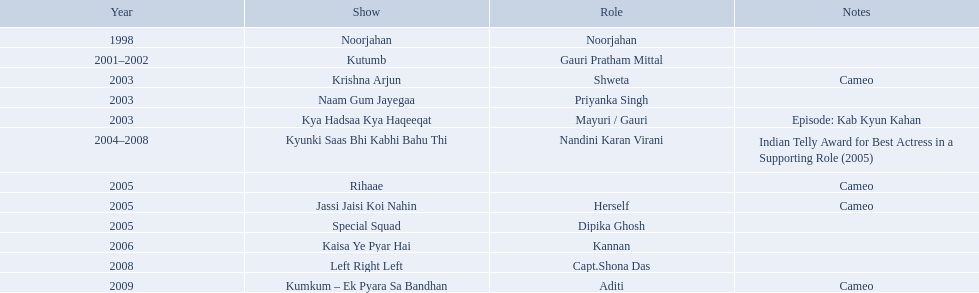What role  was played for the latest show Cameo. Who played the last cameo before ? Jassi Jaisi Koi Nahin. How many shows are there? Noorjahan, Kutumb, Krishna Arjun, Naam Gum Jayegaa, Kya Hadsaa Kya Haqeeqat, Kyunki Saas Bhi Kabhi Bahu Thi, Rihaae, Jassi Jaisi Koi Nahin, Special Squad, Kaisa Ye Pyar Hai, Left Right Left, Kumkum – Ek Pyara Sa Bandhan. Can you parse all the data within this table? {'header': ['Year', 'Show', 'Role', 'Notes'], 'rows': [['1998', 'Noorjahan', 'Noorjahan', ''], ['2001–2002', 'Kutumb', 'Gauri Pratham Mittal', ''], ['2003', 'Krishna Arjun', 'Shweta', 'Cameo'], ['2003', 'Naam Gum Jayegaa', 'Priyanka Singh', ''], ['2003', 'Kya Hadsaa Kya Haqeeqat', 'Mayuri / Gauri', 'Episode: Kab Kyun Kahan'], ['2004–2008', 'Kyunki Saas Bhi Kabhi Bahu Thi', 'Nandini Karan Virani', 'Indian Telly Award for Best Actress in a Supporting Role (2005)'], ['2005', 'Rihaae', '', 'Cameo'], ['2005', 'Jassi Jaisi Koi Nahin', 'Herself', 'Cameo'], ['2005', 'Special Squad', 'Dipika Ghosh', ''], ['2006', 'Kaisa Ye Pyar Hai', 'Kannan', ''], ['2008', 'Left Right Left', 'Capt.Shona Das', ''], ['2009', 'Kumkum – Ek Pyara Sa Bandhan', 'Aditi', 'Cameo']]} How many shows did she make a cameo appearance? Krishna Arjun, Rihaae, Jassi Jaisi Koi Nahin, Kumkum – Ek Pyara Sa Bandhan. Of those, how many did she play herself? Jassi Jaisi Koi Nahin. On what shows did gauri pradhan tejwani appear after 2000? Kutumb, Krishna Arjun, Naam Gum Jayegaa, Kya Hadsaa Kya Haqeeqat, Kyunki Saas Bhi Kabhi Bahu Thi, Rihaae, Jassi Jaisi Koi Nahin, Special Squad, Kaisa Ye Pyar Hai, Left Right Left, Kumkum – Ek Pyara Sa Bandhan. In which of them was is a cameo appearance? Krishna Arjun, Rihaae, Jassi Jaisi Koi Nahin, Kumkum – Ek Pyara Sa Bandhan. Of these which one did she play the role of herself? Jassi Jaisi Koi Nahin. In 1998 what was the role of gauri pradhan tejwani? Noorjahan. In 2003 what show did gauri have a cameo in? Krishna Arjun. Gauri was apart of which television show for the longest? Kyunki Saas Bhi Kabhi Bahu Thi. In which tv shows has gauri pradhan tejwani acted? Noorjahan, Kutumb, Krishna Arjun, Naam Gum Jayegaa, Kya Hadsaa Kya Haqeeqat, Kyunki Saas Bhi Kabhi Bahu Thi, Rihaae, Jassi Jaisi Koi Nahin, Special Squad, Kaisa Ye Pyar Hai, Left Right Left, Kumkum – Ek Pyara Sa Bandhan. From those shows, which one went on for over a year? Kutumb, Kyunki Saas Bhi Kabhi Bahu Thi. Which of these had the lengthiest run? Kyunki Saas Bhi Kabhi Bahu Thi. In which programs did gauri tejwani participate? Noorjahan, Kutumb, Krishna Arjun, Naam Gum Jayegaa, Kya Hadsaa Kya Haqeeqat, Kyunki Saas Bhi Kabhi Bahu Thi, Rihaae, Jassi Jaisi Koi Nahin, Special Squad, Kaisa Ye Pyar Hai, Left Right Left, Kumkum – Ek Pyara Sa Bandhan. What were the 2005 programs? Rihaae, Jassi Jaisi Koi Nahin, Special Squad. Which ones were guest appearances? Rihaae, Jassi Jaisi Koi Nahin. In which of these, was it not rihaee? Jassi Jaisi Koi Nahin. In 1998, what position did gauri pradhan tejwani hold? Noorjahan. In 2003, in which show did gauri make a cameo appearance? Krishna Arjun. For the longest period, gauri was a part of which tv show? Kyunki Saas Bhi Kabhi Bahu Thi. What programs has gauri pradhan tejwani participated in? Noorjahan, Kutumb, Krishna Arjun, Naam Gum Jayegaa, Kya Hadsaa Kya Haqeeqat, Kyunki Saas Bhi Kabhi Bahu Thi, Rihaae, Jassi Jaisi Koi Nahin, Special Squad, Kaisa Ye Pyar Hai, Left Right Left, Kumkum – Ek Pyara Sa Bandhan. Give me the full table as a dictionary. {'header': ['Year', 'Show', 'Role', 'Notes'], 'rows': [['1998', 'Noorjahan', 'Noorjahan', ''], ['2001–2002', 'Kutumb', 'Gauri Pratham Mittal', ''], ['2003', 'Krishna Arjun', 'Shweta', 'Cameo'], ['2003', 'Naam Gum Jayegaa', 'Priyanka Singh', ''], ['2003', 'Kya Hadsaa Kya Haqeeqat', 'Mayuri / Gauri', 'Episode: Kab Kyun Kahan'], ['2004–2008', 'Kyunki Saas Bhi Kabhi Bahu Thi', 'Nandini Karan Virani', 'Indian Telly Award for Best Actress in a Supporting Role (2005)'], ['2005', 'Rihaae', '', 'Cameo'], ['2005', 'Jassi Jaisi Koi Nahin', 'Herself', 'Cameo'], ['2005', 'Special Squad', 'Dipika Ghosh', ''], ['2006', 'Kaisa Ye Pyar Hai', 'Kannan', ''], ['2008', 'Left Right Left', 'Capt.Shona Das', ''], ['2009', 'Kumkum – Ek Pyara Sa Bandhan', 'Aditi', 'Cameo']]} Out of them, which one extended for more than a year? Kutumb, Kyunki Saas Bhi Kabhi Bahu Thi. Which one persisted the longest? Kyunki Saas Bhi Kabhi Bahu Thi. What are all the productions? Noorjahan, Kutumb, Krishna Arjun, Naam Gum Jayegaa, Kya Hadsaa Kya Haqeeqat, Kyunki Saas Bhi Kabhi Bahu Thi, Rihaae, Jassi Jaisi Koi Nahin, Special Squad, Kaisa Ye Pyar Hai, Left Right Left, Kumkum – Ek Pyara Sa Bandhan. When were they being created? 1998, 2001–2002, 2003, 2003, 2003, 2004–2008, 2005, 2005, 2005, 2006, 2008, 2009. And on which show did he have the longest tenure? Kyunki Saas Bhi Kabhi Bahu Thi. How many productions are there? Noorjahan, Kutumb, Krishna Arjun, Naam Gum Jayegaa, Kya Hadsaa Kya Haqeeqat, Kyunki Saas Bhi Kabhi Bahu Thi, Rihaae, Jassi Jaisi Koi Nahin, Special Squad, Kaisa Ye Pyar Hai, Left Right Left, Kumkum – Ek Pyara Sa Bandhan. How many productions did she make a short appearance in? Krishna Arjun, Rihaae, Jassi Jaisi Koi Nahin, Kumkum – Ek Pyara Sa Bandhan. Of those, how many did she represent herself? Jassi Jaisi Koi Nahin. What are all the series? Noorjahan, Kutumb, Krishna Arjun, Naam Gum Jayegaa, Kya Hadsaa Kya Haqeeqat, Kyunki Saas Bhi Kabhi Bahu Thi, Rihaae, Jassi Jaisi Koi Nahin, Special Squad, Kaisa Ye Pyar Hai, Left Right Left, Kumkum – Ek Pyara Sa Bandhan. When were they being produced? 1998, 2001–2002, 2003, 2003, 2003, 2004–2008, 2005, 2005, 2005, 2006, 2008, 2009. And which series did he stay on for the longest duration? Kyunki Saas Bhi Kabhi Bahu Thi. In which programs did gauri tejwani appear? Noorjahan, Kutumb, Krishna Arjun, Naam Gum Jayegaa, Kya Hadsaa Kya Haqeeqat, Kyunki Saas Bhi Kabhi Bahu Thi, Rihaae, Jassi Jaisi Koi Nahin, Special Squad, Kaisa Ye Pyar Hai, Left Right Left, Kumkum – Ek Pyara Sa Bandhan. What were the shows from 2005? Rihaae, Jassi Jaisi Koi Nahin, Special Squad. Which ones were guest appearances? Rihaae, Jassi Jaisi Koi Nahin. Which of these was not rihaee? Jassi Jaisi Koi Nahin. What were the television series that featured gauri tejwani? Noorjahan, Kutumb, Krishna Arjun, Naam Gum Jayegaa, Kya Hadsaa Kya Haqeeqat, Kyunki Saas Bhi Kabhi Bahu Thi, Rihaae, Jassi Jaisi Koi Nahin, Special Squad, Kaisa Ye Pyar Hai, Left Right Left, Kumkum – Ek Pyara Sa Bandhan. What were the 2005 series? Rihaae, Jassi Jaisi Koi Nahin, Special Squad. Which ones included cameo roles? Rihaae, Jassi Jaisi Koi Nahin. Which of them was not rihaee? Jassi Jaisi Koi Nahin. What is the total number of shows? Noorjahan, Kutumb, Krishna Arjun, Naam Gum Jayegaa, Kya Hadsaa Kya Haqeeqat, Kyunki Saas Bhi Kabhi Bahu Thi, Rihaae, Jassi Jaisi Koi Nahin, Special Squad, Kaisa Ye Pyar Hai, Left Right Left, Kumkum – Ek Pyara Sa Bandhan. In how many shows did she have a cameo role? Krishna Arjun, Rihaae, Jassi Jaisi Koi Nahin, Kumkum – Ek Pyara Sa Bandhan. In how many of those appearances did she portray herself? Jassi Jaisi Koi Nahin. Can you parse all the data within this table? {'header': ['Year', 'Show', 'Role', 'Notes'], 'rows': [['1998', 'Noorjahan', 'Noorjahan', ''], ['2001–2002', 'Kutumb', 'Gauri Pratham Mittal', ''], ['2003', 'Krishna Arjun', 'Shweta', 'Cameo'], ['2003', 'Naam Gum Jayegaa', 'Priyanka Singh', ''], ['2003', 'Kya Hadsaa Kya Haqeeqat', 'Mayuri / Gauri', 'Episode: Kab Kyun Kahan'], ['2004–2008', 'Kyunki Saas Bhi Kabhi Bahu Thi', 'Nandini Karan Virani', 'Indian Telly Award for Best Actress in a Supporting Role (2005)'], ['2005', 'Rihaae', '', 'Cameo'], ['2005', 'Jassi Jaisi Koi Nahin', 'Herself', 'Cameo'], ['2005', 'Special Squad', 'Dipika Ghosh', ''], ['2006', 'Kaisa Ye Pyar Hai', 'Kannan', ''], ['2008', 'Left Right Left', 'Capt.Shona Das', ''], ['2009', 'Kumkum – Ek Pyara Sa Bandhan', 'Aditi', 'Cameo']]} What is the count of shows? Noorjahan, Kutumb, Krishna Arjun, Naam Gum Jayegaa, Kya Hadsaa Kya Haqeeqat, Kyunki Saas Bhi Kabhi Bahu Thi, Rihaae, Jassi Jaisi Koi Nahin, Special Squad, Kaisa Ye Pyar Hai, Left Right Left, Kumkum – Ek Pyara Sa Bandhan. In how many of those shows did she make a cameo appearance? Krishna Arjun, Rihaae, Jassi Jaisi Koi Nahin, Kumkum – Ek Pyara Sa Bandhan. Out of those, in how many did she act as herself? Jassi Jaisi Koi Nahin. What is the complete list of shows? Noorjahan, Kutumb, Krishna Arjun, Naam Gum Jayegaa, Kya Hadsaa Kya Haqeeqat, Kyunki Saas Bhi Kabhi Bahu Thi, Rihaae, Jassi Jaisi Koi Nahin, Special Squad, Kaisa Ye Pyar Hai, Left Right Left, Kumkum – Ek Pyara Sa Bandhan. When were they produced? 1998, 2001–2002, 2003, 2003, 2003, 2004–2008, 2005, 2005, 2005, 2006, 2008, 2009. And on which show did he spend the most time? Kyunki Saas Bhi Kabhi Bahu Thi. What was gauri pradhan tejwani's responsibility in 1998? Noorjahan. Which program included a cameo by gauri in 2003? Krishna Arjun. Which tv show had gauri as a part for an extended period? Kyunki Saas Bhi Kabhi Bahu Thi. 